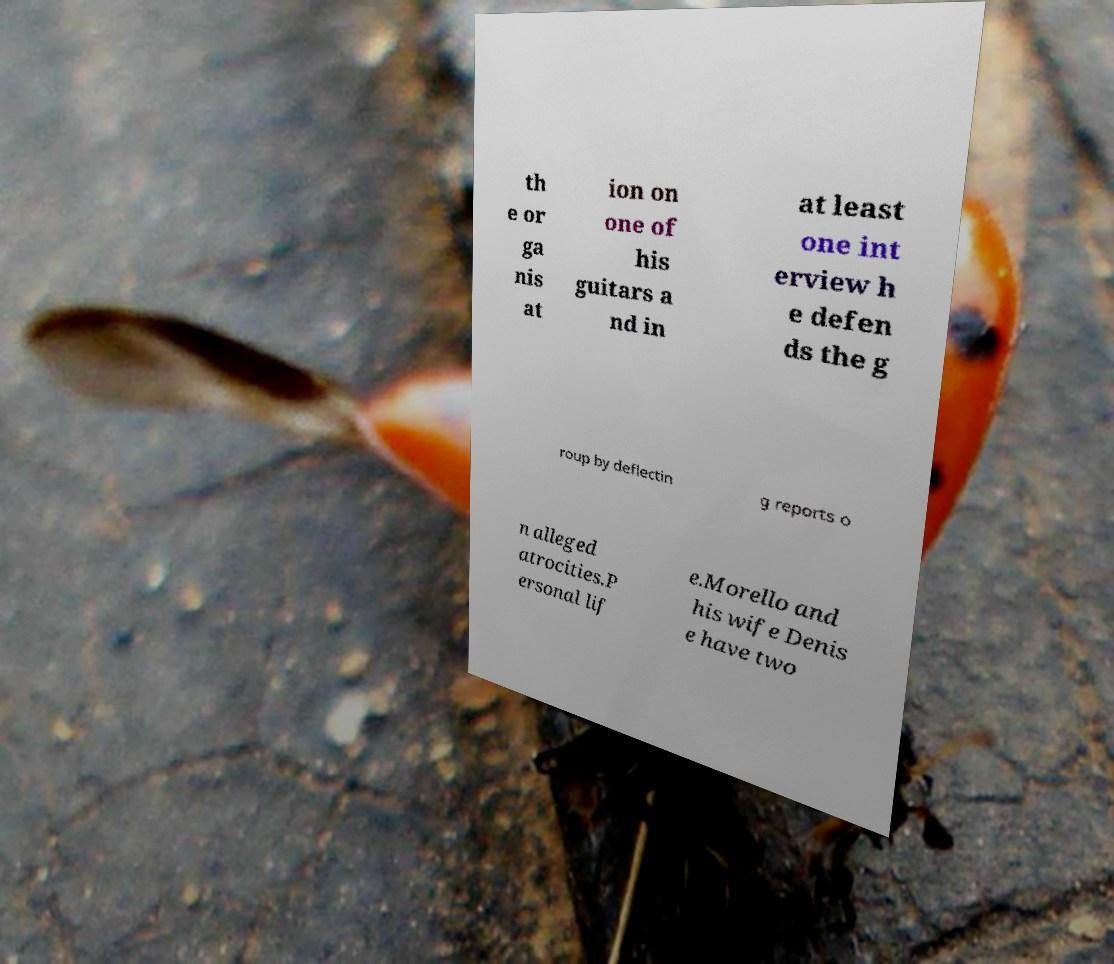Can you read and provide the text displayed in the image?This photo seems to have some interesting text. Can you extract and type it out for me? th e or ga nis at ion on one of his guitars a nd in at least one int erview h e defen ds the g roup by deflectin g reports o n alleged atrocities.P ersonal lif e.Morello and his wife Denis e have two 